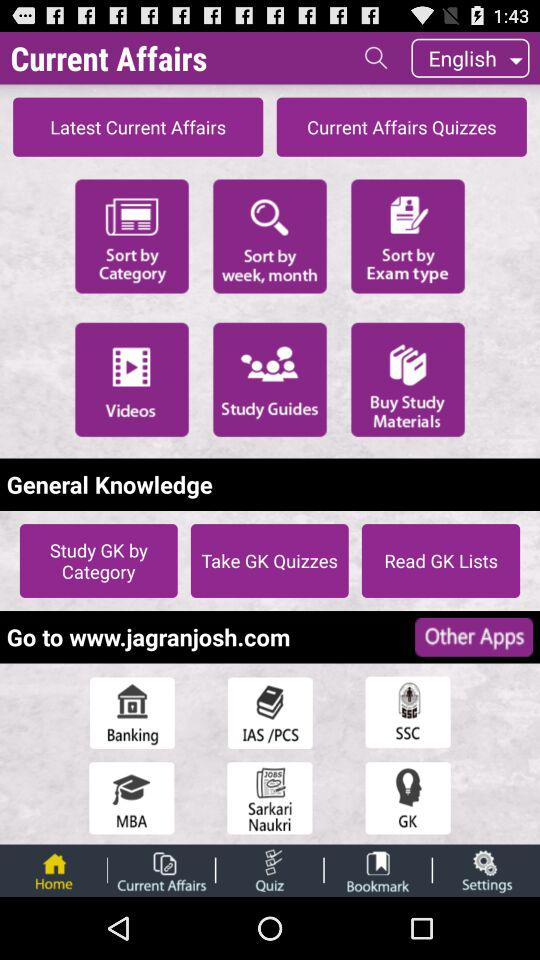Which tab is selected? The selected tab is "Home". 